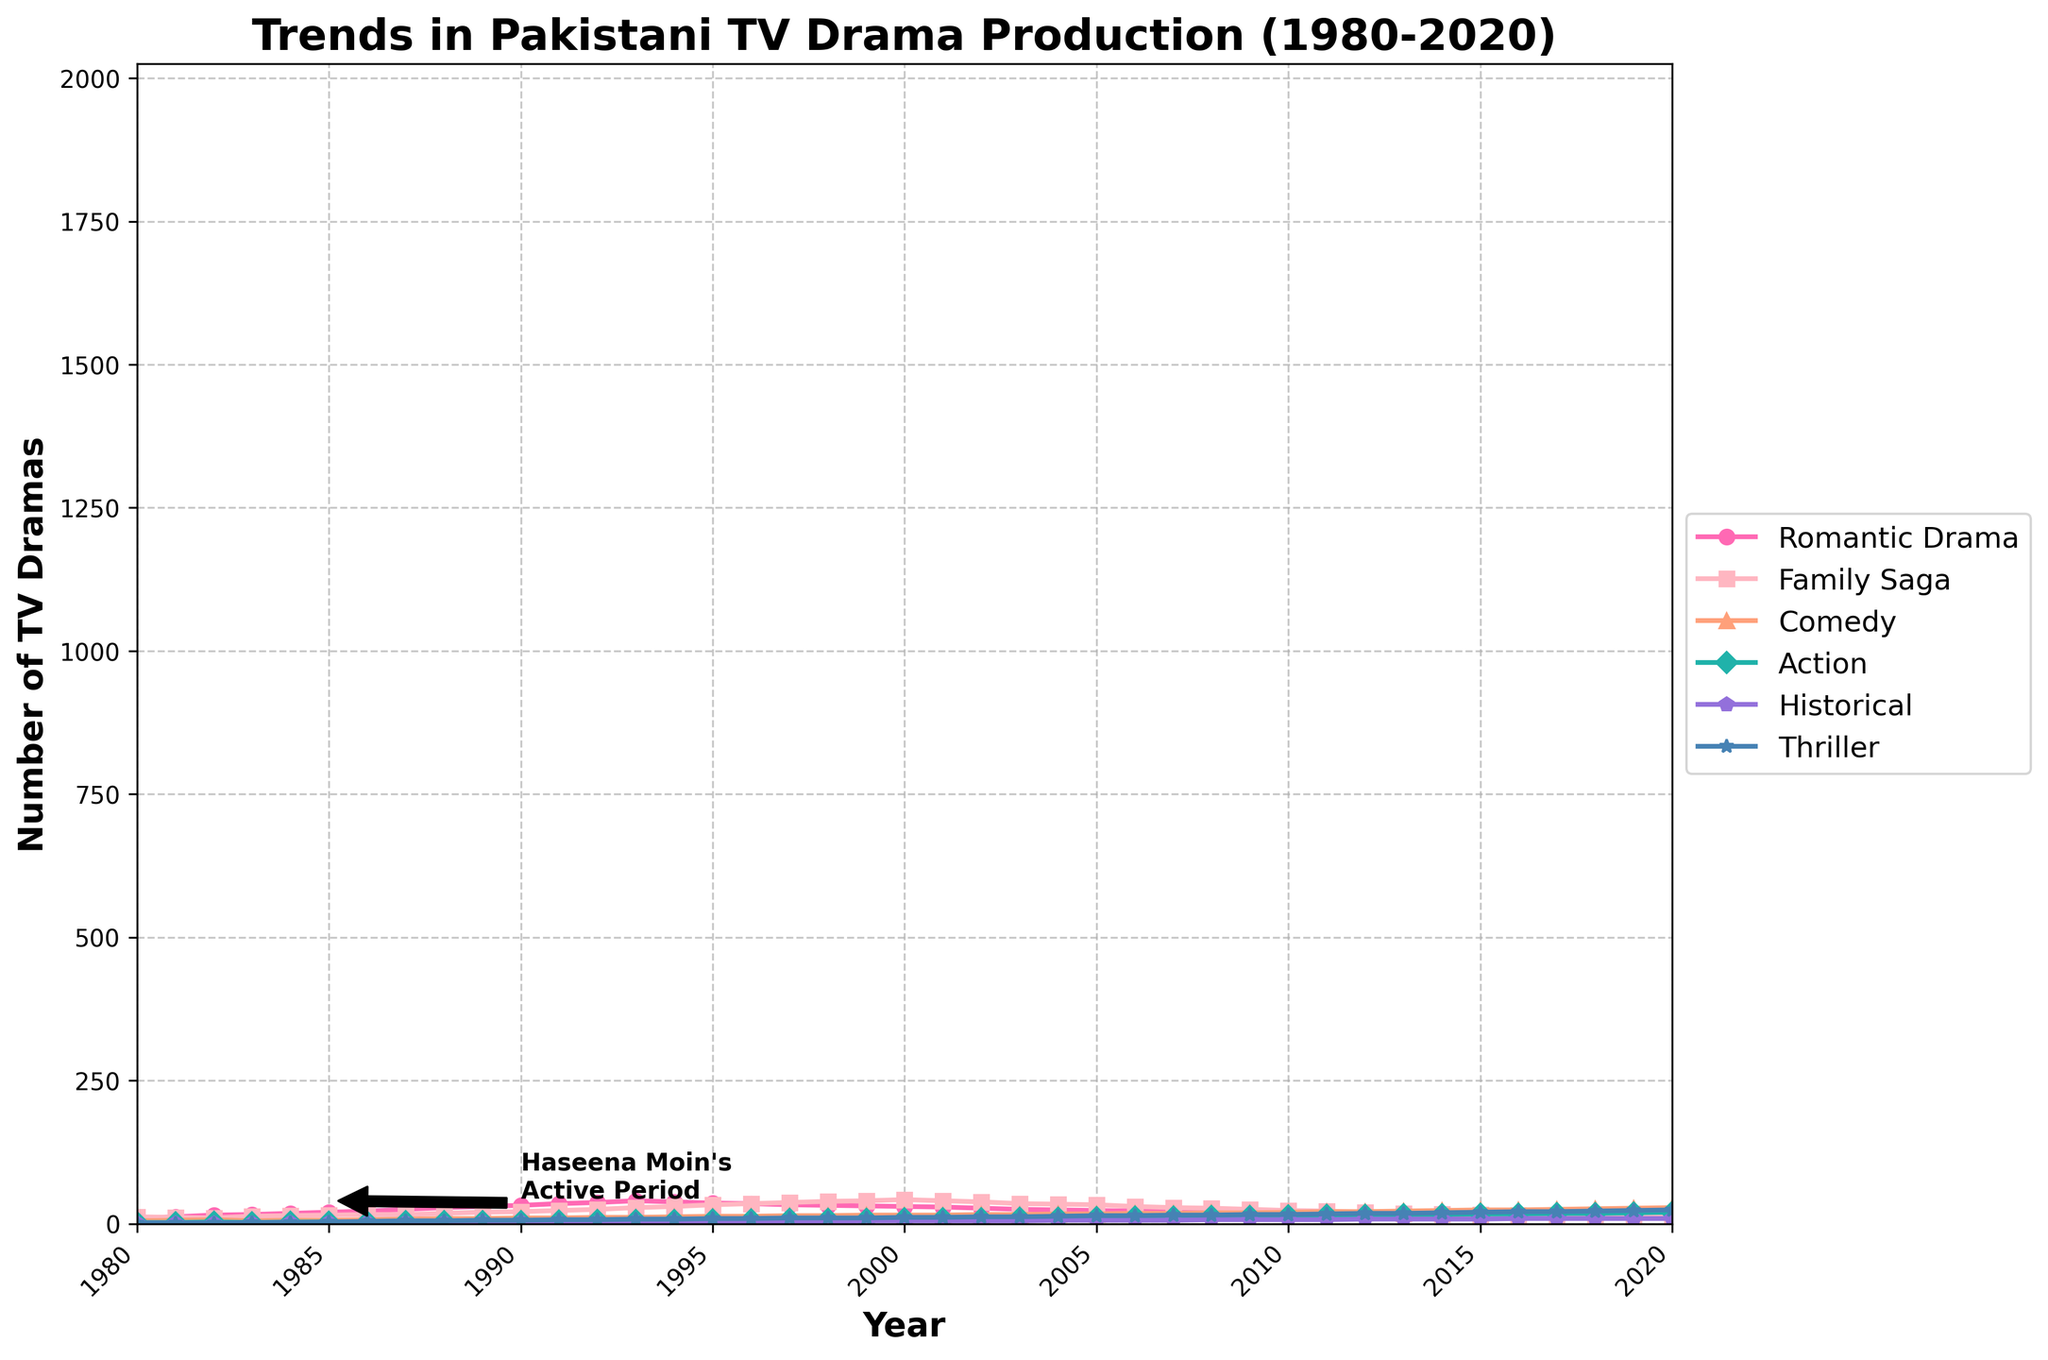How many different genres of TV dramas are shown in the figure? The figure shows six different genres of TV dramas, which are Romantic Drama, Family Saga, Comedy, Action, Historical, and Thriller. You can see this from the legend on the right side of the plot where all genres are listed.
Answer: Six What year did Romantic Dramas peak in number? To determine the peak year for Romantic Dramas in terms of production number, look at the highest point in the Romantic Drama curve, which is indicated with a specific marker and color. The highest point can be found around the year 1993.
Answer: 1993 During Haseena Moin's active period, which genre showed the most significant growth? During Haseena Moin's active period annotated from around 1985 to the early 1990s, the Romantic Drama genre showed the most significant growth. This can be seen by the steep increase in the number of Romantic Drama productions during that time.
Answer: Romantic Drama How many Romantic Dramas were produced in 1989? Locate the year 1989 on the x-axis and find the corresponding value for Romantic Dramas on the plot. For 1989, the number of Romantic Dramas is indicated to be 30.
Answer: 30 Which genre showed an increase in production from 1980 to 2020 without any decline? By examining the trends of each genre from 1980 to 2020, we can see that the Thriller genre consistently increased over this period without any decline. The Thriller curve has a steadily upward slope throughout the entire timeframe.
Answer: Thriller Compare the number of Family Saga dramas produced in 1995 and 2020. To compare the numbers, look at the datapoints for Family Saga in 1995 and 2020. In 1995, the number of Family Sagas is 33, while in 2020, it is 12.
Answer: More were produced in 1995 What is the average number of Comedy dramas produced per year between 1980 and 1990? First, find the number of Comedy dramas produced each year between 1980 and 1990, which are 5, 6, 7, 5, 6, 6, 7, 8, 9, 9, and 10. Sum these values and then divide by 11 (the number of years). The sum is (5+6+7+5+6+6+7+8+9+9+10) = 78. The average is 78/11 = 7.09.
Answer: 7.09 In which year did Action dramas first exceed 10 productions? Look for the year where the Action drama curve first exceeds the value 10 on the y-axis. This occurs in the year 2005, where the number exceeds 10 for the first time.
Answer: 2005 What is the trend in Historical dramas between 2000 and 2020? To identify the trend, observe the curve for Historical dramas from 2000 to 2020. The trend appears fairly stable with minor fluctuations, staying around the same number without significant increases or decreases.
Answer: Stable with minor fluctuations 